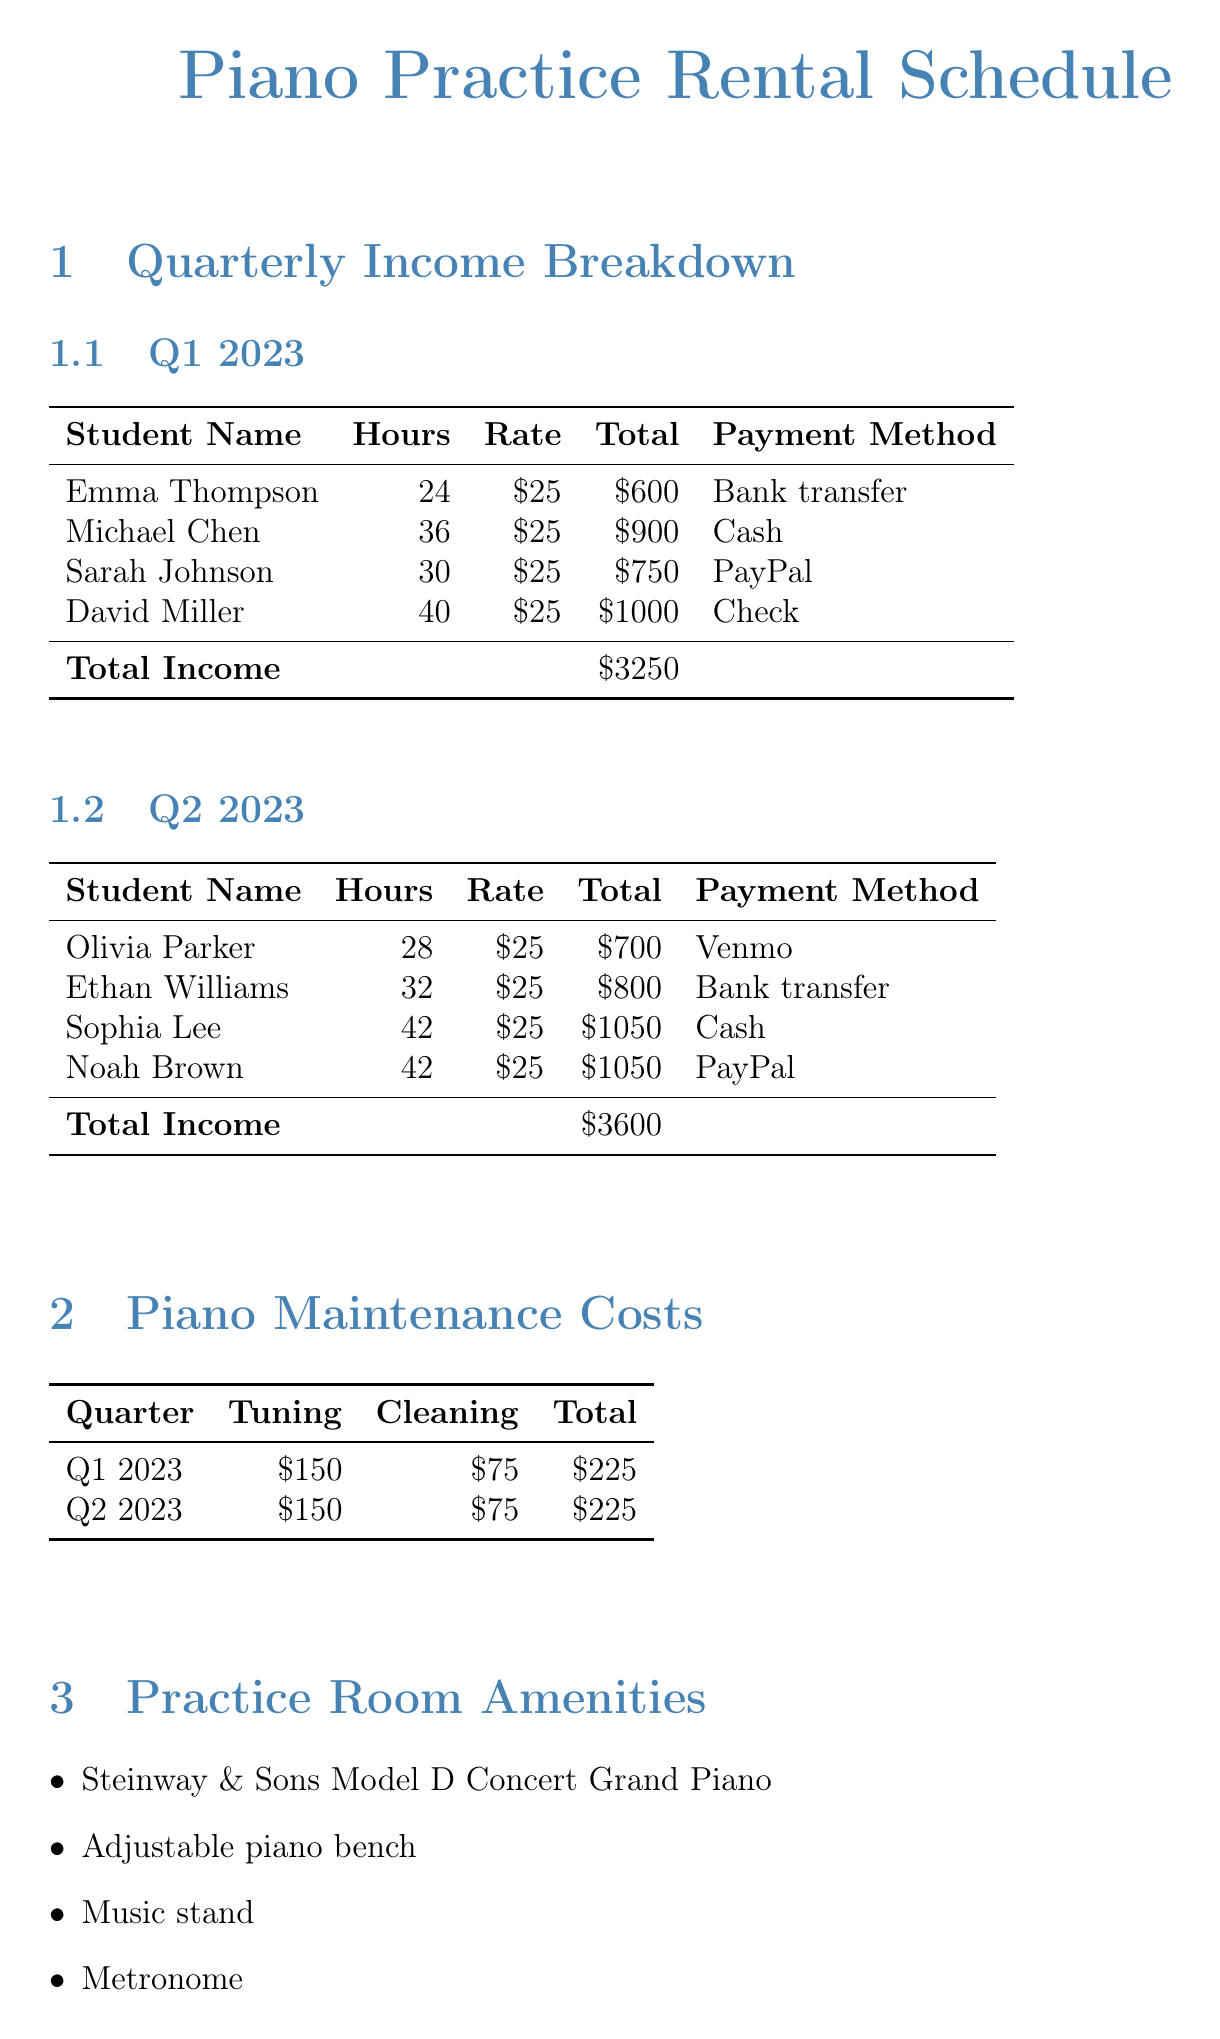What was the total income for Q1 2023? The total income for Q1 2023 is specifically listed in the document as $3250.
Answer: $3250 Who paid using Venmo in Q2 2023? The document specifies that Olivia Parker is the student who paid using Venmo for her rental sessions.
Answer: Olivia Parker What is the total maintenance cost for Q2 2023? The total maintenance cost for Q2 2023 is detailed as $225 in the maintenance section of the document.
Answer: $225 How many hours did Sarah Johnson rent the piano? The document states that Sarah Johnson rented the piano for a total of 30 hours in Q1 2023.
Answer: 30 What is the cleaning cost for Q1 2023 maintenance? The cleaning cost for Q1 2023 is explicitly indicated in the document as $75.
Answer: $75 How many students rented the piano in Q2 2023? The document lists four students who rented the piano during Q2 2023, providing their names in the breakdown.
Answer: Four What is the maximum booking time per day according to rental policies? The rental policies state that the maximum booking time allowed per day is 4 hours, found in the policies section of the document.
Answer: 4 hours What payment tracking method is used for cash payments? The document specifies that a paper receipt book is used for tracking cash payments.
Answer: Paper receipt book 